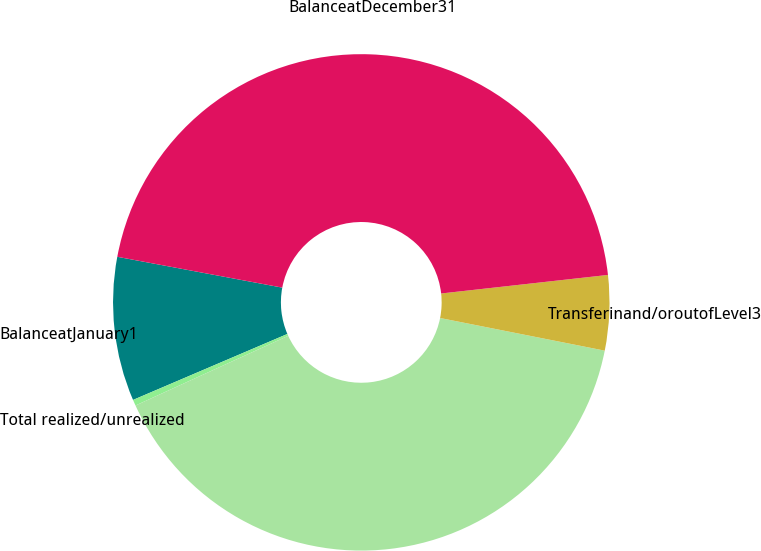Convert chart. <chart><loc_0><loc_0><loc_500><loc_500><pie_chart><fcel>BalanceatJanuary1<fcel>Total realized/unrealized<fcel>Unnamed: 2<fcel>Transferinand/oroutofLevel3<fcel>BalanceatDecember31<nl><fcel>9.37%<fcel>0.39%<fcel>40.07%<fcel>4.88%<fcel>45.3%<nl></chart> 